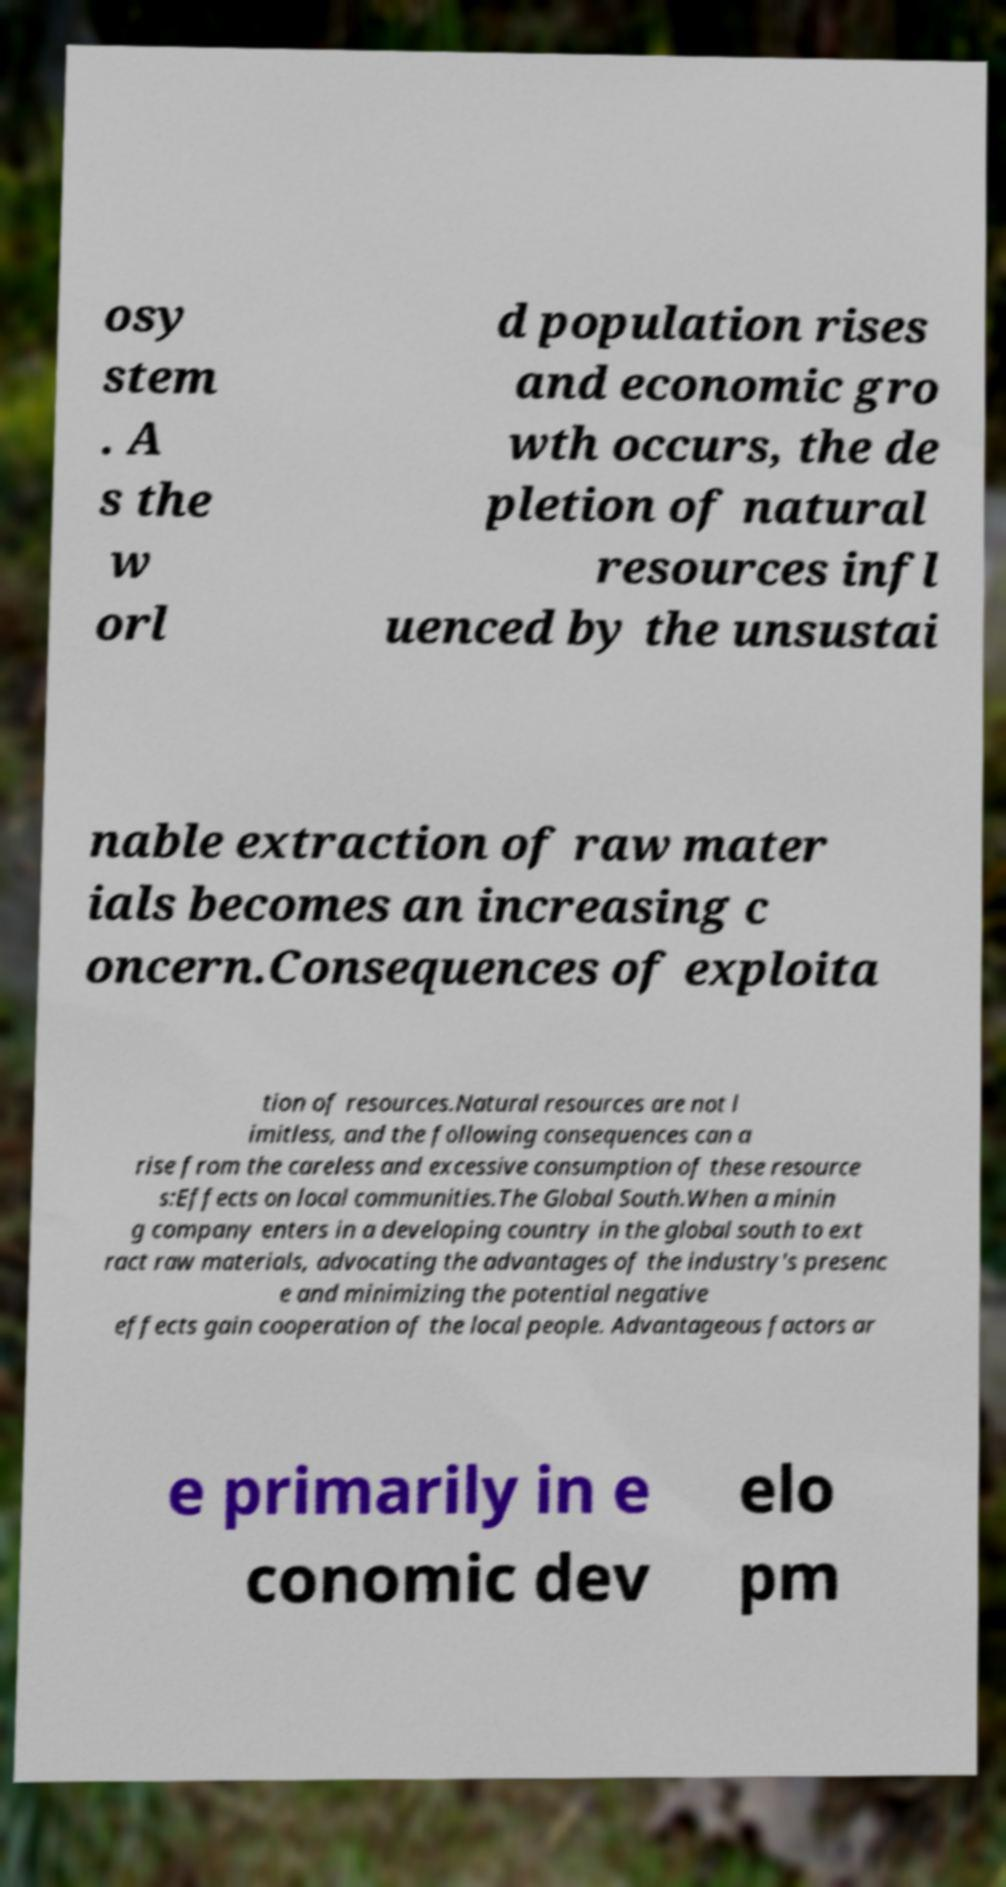What messages or text are displayed in this image? I need them in a readable, typed format. osy stem . A s the w orl d population rises and economic gro wth occurs, the de pletion of natural resources infl uenced by the unsustai nable extraction of raw mater ials becomes an increasing c oncern.Consequences of exploita tion of resources.Natural resources are not l imitless, and the following consequences can a rise from the careless and excessive consumption of these resource s:Effects on local communities.The Global South.When a minin g company enters in a developing country in the global south to ext ract raw materials, advocating the advantages of the industry's presenc e and minimizing the potential negative effects gain cooperation of the local people. Advantageous factors ar e primarily in e conomic dev elo pm 